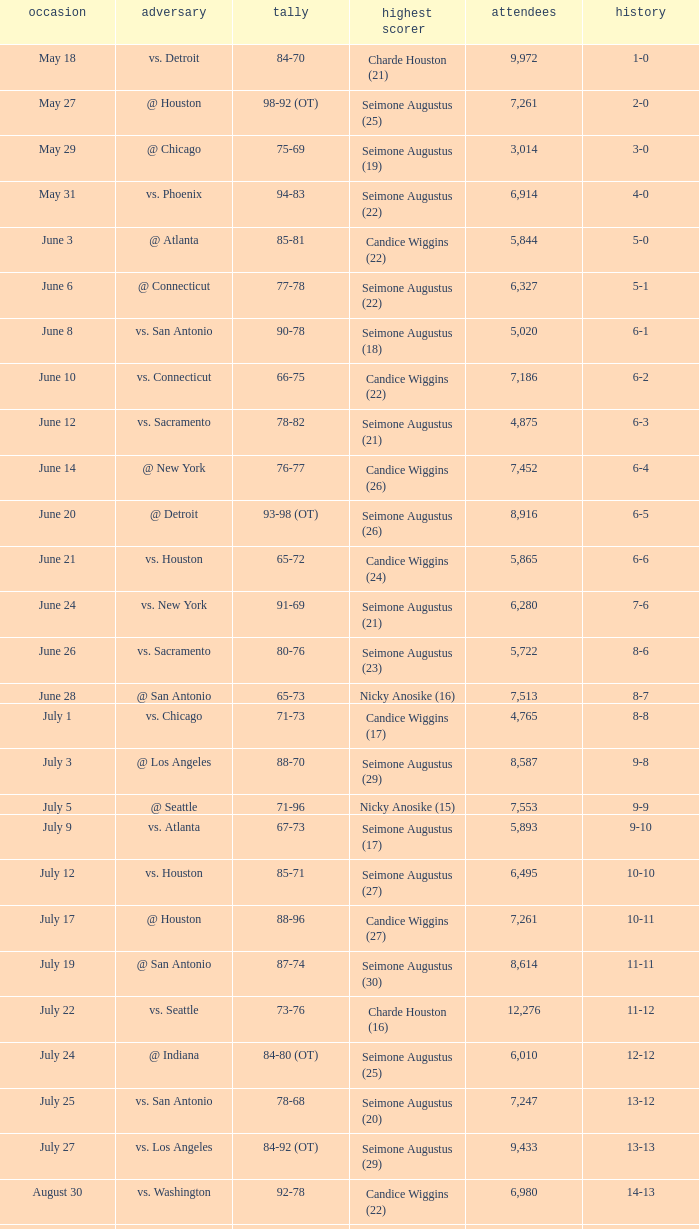Which Leading Scorer has an Opponent of @ seattle, and a Record of 14-16? Seimone Augustus (26). 